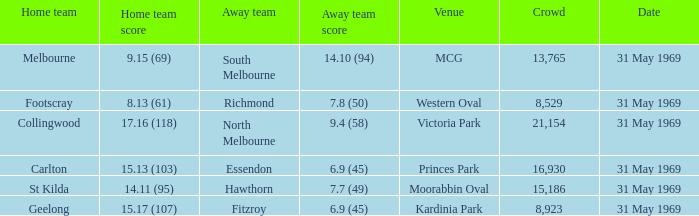Which was the host team that participated in victoria park? Collingwood. 